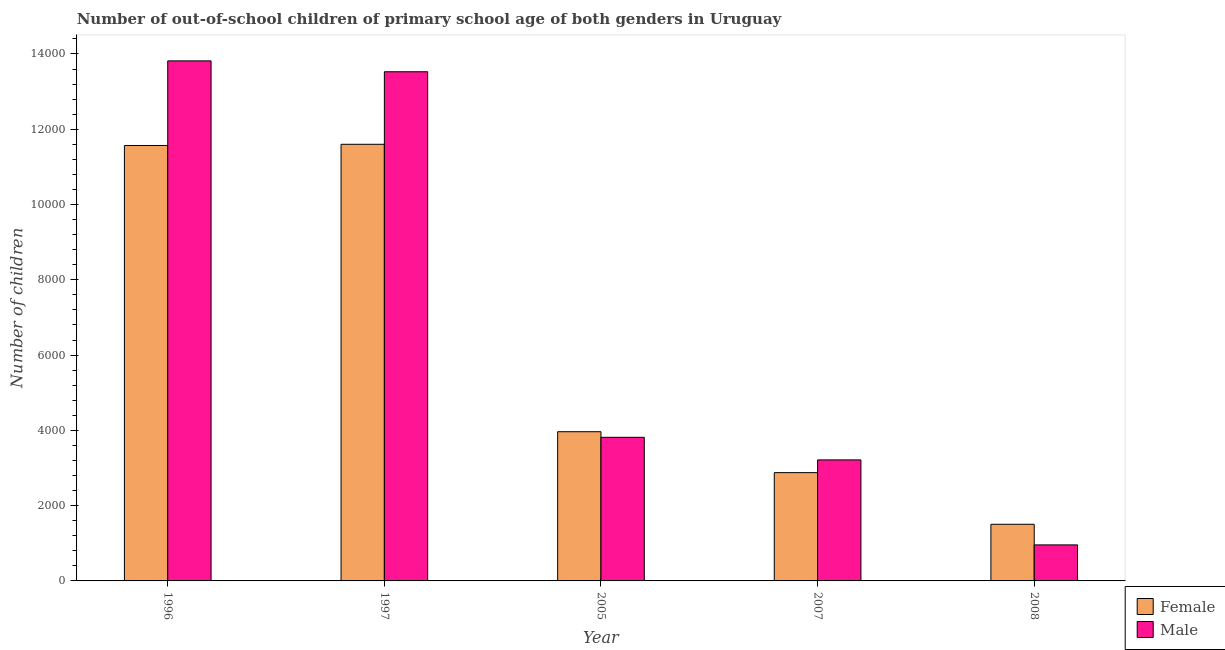How many groups of bars are there?
Keep it short and to the point. 5. How many bars are there on the 5th tick from the right?
Your response must be concise. 2. What is the label of the 2nd group of bars from the left?
Make the answer very short. 1997. What is the number of female out-of-school students in 2007?
Offer a very short reply. 2877. Across all years, what is the maximum number of male out-of-school students?
Provide a short and direct response. 1.38e+04. Across all years, what is the minimum number of female out-of-school students?
Provide a short and direct response. 1505. What is the total number of male out-of-school students in the graph?
Offer a terse response. 3.53e+04. What is the difference between the number of male out-of-school students in 1997 and that in 2005?
Provide a succinct answer. 9712. What is the difference between the number of male out-of-school students in 1996 and the number of female out-of-school students in 2007?
Offer a terse response. 1.06e+04. What is the average number of male out-of-school students per year?
Provide a succinct answer. 7066. In how many years, is the number of female out-of-school students greater than 13200?
Offer a very short reply. 0. What is the ratio of the number of female out-of-school students in 1996 to that in 1997?
Give a very brief answer. 1. What is the difference between the highest and the lowest number of female out-of-school students?
Your answer should be very brief. 1.01e+04. How many years are there in the graph?
Provide a succinct answer. 5. Are the values on the major ticks of Y-axis written in scientific E-notation?
Your answer should be very brief. No. How many legend labels are there?
Provide a short and direct response. 2. How are the legend labels stacked?
Keep it short and to the point. Vertical. What is the title of the graph?
Your answer should be very brief. Number of out-of-school children of primary school age of both genders in Uruguay. Does "Export" appear as one of the legend labels in the graph?
Ensure brevity in your answer.  No. What is the label or title of the X-axis?
Offer a terse response. Year. What is the label or title of the Y-axis?
Make the answer very short. Number of children. What is the Number of children in Female in 1996?
Give a very brief answer. 1.16e+04. What is the Number of children in Male in 1996?
Make the answer very short. 1.38e+04. What is the Number of children of Female in 1997?
Give a very brief answer. 1.16e+04. What is the Number of children of Male in 1997?
Provide a short and direct response. 1.35e+04. What is the Number of children in Female in 2005?
Offer a terse response. 3964. What is the Number of children of Male in 2005?
Your response must be concise. 3815. What is the Number of children in Female in 2007?
Provide a succinct answer. 2877. What is the Number of children in Male in 2007?
Provide a succinct answer. 3215. What is the Number of children of Female in 2008?
Ensure brevity in your answer.  1505. What is the Number of children of Male in 2008?
Your answer should be compact. 957. Across all years, what is the maximum Number of children in Female?
Keep it short and to the point. 1.16e+04. Across all years, what is the maximum Number of children of Male?
Give a very brief answer. 1.38e+04. Across all years, what is the minimum Number of children in Female?
Make the answer very short. 1505. Across all years, what is the minimum Number of children of Male?
Your response must be concise. 957. What is the total Number of children of Female in the graph?
Provide a short and direct response. 3.15e+04. What is the total Number of children of Male in the graph?
Make the answer very short. 3.53e+04. What is the difference between the Number of children in Female in 1996 and that in 1997?
Provide a succinct answer. -32. What is the difference between the Number of children of Male in 1996 and that in 1997?
Keep it short and to the point. 289. What is the difference between the Number of children in Female in 1996 and that in 2005?
Keep it short and to the point. 7604. What is the difference between the Number of children in Male in 1996 and that in 2005?
Make the answer very short. 1.00e+04. What is the difference between the Number of children in Female in 1996 and that in 2007?
Provide a short and direct response. 8691. What is the difference between the Number of children of Male in 1996 and that in 2007?
Give a very brief answer. 1.06e+04. What is the difference between the Number of children of Female in 1996 and that in 2008?
Your response must be concise. 1.01e+04. What is the difference between the Number of children in Male in 1996 and that in 2008?
Provide a succinct answer. 1.29e+04. What is the difference between the Number of children in Female in 1997 and that in 2005?
Offer a terse response. 7636. What is the difference between the Number of children in Male in 1997 and that in 2005?
Ensure brevity in your answer.  9712. What is the difference between the Number of children of Female in 1997 and that in 2007?
Ensure brevity in your answer.  8723. What is the difference between the Number of children of Male in 1997 and that in 2007?
Your answer should be very brief. 1.03e+04. What is the difference between the Number of children in Female in 1997 and that in 2008?
Ensure brevity in your answer.  1.01e+04. What is the difference between the Number of children in Male in 1997 and that in 2008?
Provide a short and direct response. 1.26e+04. What is the difference between the Number of children of Female in 2005 and that in 2007?
Your answer should be compact. 1087. What is the difference between the Number of children in Male in 2005 and that in 2007?
Provide a short and direct response. 600. What is the difference between the Number of children of Female in 2005 and that in 2008?
Give a very brief answer. 2459. What is the difference between the Number of children in Male in 2005 and that in 2008?
Keep it short and to the point. 2858. What is the difference between the Number of children of Female in 2007 and that in 2008?
Offer a terse response. 1372. What is the difference between the Number of children of Male in 2007 and that in 2008?
Provide a short and direct response. 2258. What is the difference between the Number of children of Female in 1996 and the Number of children of Male in 1997?
Provide a succinct answer. -1959. What is the difference between the Number of children in Female in 1996 and the Number of children in Male in 2005?
Your response must be concise. 7753. What is the difference between the Number of children of Female in 1996 and the Number of children of Male in 2007?
Offer a very short reply. 8353. What is the difference between the Number of children in Female in 1996 and the Number of children in Male in 2008?
Keep it short and to the point. 1.06e+04. What is the difference between the Number of children in Female in 1997 and the Number of children in Male in 2005?
Give a very brief answer. 7785. What is the difference between the Number of children in Female in 1997 and the Number of children in Male in 2007?
Your answer should be compact. 8385. What is the difference between the Number of children in Female in 1997 and the Number of children in Male in 2008?
Give a very brief answer. 1.06e+04. What is the difference between the Number of children in Female in 2005 and the Number of children in Male in 2007?
Your answer should be very brief. 749. What is the difference between the Number of children of Female in 2005 and the Number of children of Male in 2008?
Offer a terse response. 3007. What is the difference between the Number of children of Female in 2007 and the Number of children of Male in 2008?
Provide a succinct answer. 1920. What is the average Number of children of Female per year?
Offer a terse response. 6302.8. What is the average Number of children of Male per year?
Ensure brevity in your answer.  7066. In the year 1996, what is the difference between the Number of children of Female and Number of children of Male?
Offer a terse response. -2248. In the year 1997, what is the difference between the Number of children in Female and Number of children in Male?
Ensure brevity in your answer.  -1927. In the year 2005, what is the difference between the Number of children in Female and Number of children in Male?
Give a very brief answer. 149. In the year 2007, what is the difference between the Number of children of Female and Number of children of Male?
Your answer should be very brief. -338. In the year 2008, what is the difference between the Number of children in Female and Number of children in Male?
Offer a terse response. 548. What is the ratio of the Number of children in Male in 1996 to that in 1997?
Your answer should be compact. 1.02. What is the ratio of the Number of children in Female in 1996 to that in 2005?
Provide a succinct answer. 2.92. What is the ratio of the Number of children of Male in 1996 to that in 2005?
Your answer should be compact. 3.62. What is the ratio of the Number of children in Female in 1996 to that in 2007?
Ensure brevity in your answer.  4.02. What is the ratio of the Number of children in Male in 1996 to that in 2007?
Ensure brevity in your answer.  4.3. What is the ratio of the Number of children of Female in 1996 to that in 2008?
Ensure brevity in your answer.  7.69. What is the ratio of the Number of children in Male in 1996 to that in 2008?
Your answer should be compact. 14.44. What is the ratio of the Number of children in Female in 1997 to that in 2005?
Make the answer very short. 2.93. What is the ratio of the Number of children in Male in 1997 to that in 2005?
Your response must be concise. 3.55. What is the ratio of the Number of children in Female in 1997 to that in 2007?
Your answer should be compact. 4.03. What is the ratio of the Number of children of Male in 1997 to that in 2007?
Your answer should be very brief. 4.21. What is the ratio of the Number of children in Female in 1997 to that in 2008?
Keep it short and to the point. 7.71. What is the ratio of the Number of children in Male in 1997 to that in 2008?
Offer a terse response. 14.13. What is the ratio of the Number of children in Female in 2005 to that in 2007?
Your answer should be very brief. 1.38. What is the ratio of the Number of children of Male in 2005 to that in 2007?
Ensure brevity in your answer.  1.19. What is the ratio of the Number of children of Female in 2005 to that in 2008?
Keep it short and to the point. 2.63. What is the ratio of the Number of children in Male in 2005 to that in 2008?
Make the answer very short. 3.99. What is the ratio of the Number of children of Female in 2007 to that in 2008?
Make the answer very short. 1.91. What is the ratio of the Number of children in Male in 2007 to that in 2008?
Offer a terse response. 3.36. What is the difference between the highest and the second highest Number of children of Female?
Your answer should be compact. 32. What is the difference between the highest and the second highest Number of children in Male?
Offer a terse response. 289. What is the difference between the highest and the lowest Number of children in Female?
Offer a terse response. 1.01e+04. What is the difference between the highest and the lowest Number of children of Male?
Offer a terse response. 1.29e+04. 